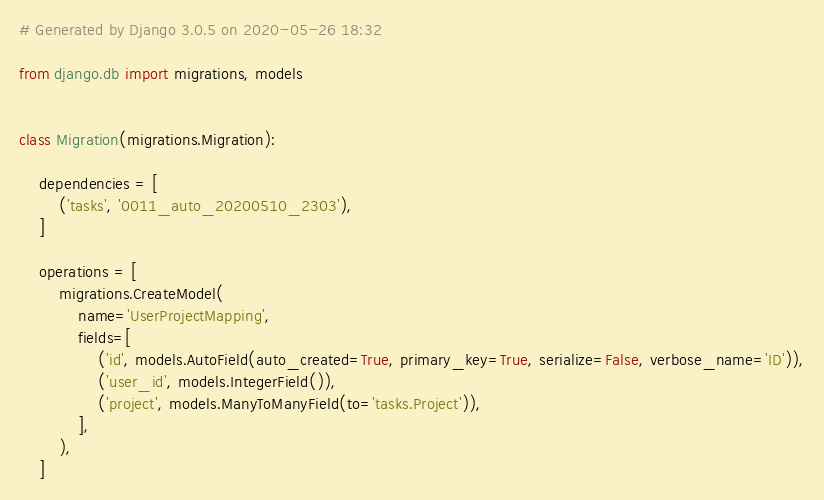Convert code to text. <code><loc_0><loc_0><loc_500><loc_500><_Python_># Generated by Django 3.0.5 on 2020-05-26 18:32

from django.db import migrations, models


class Migration(migrations.Migration):

    dependencies = [
        ('tasks', '0011_auto_20200510_2303'),
    ]

    operations = [
        migrations.CreateModel(
            name='UserProjectMapping',
            fields=[
                ('id', models.AutoField(auto_created=True, primary_key=True, serialize=False, verbose_name='ID')),
                ('user_id', models.IntegerField()),
                ('project', models.ManyToManyField(to='tasks.Project')),
            ],
        ),
    ]
</code> 